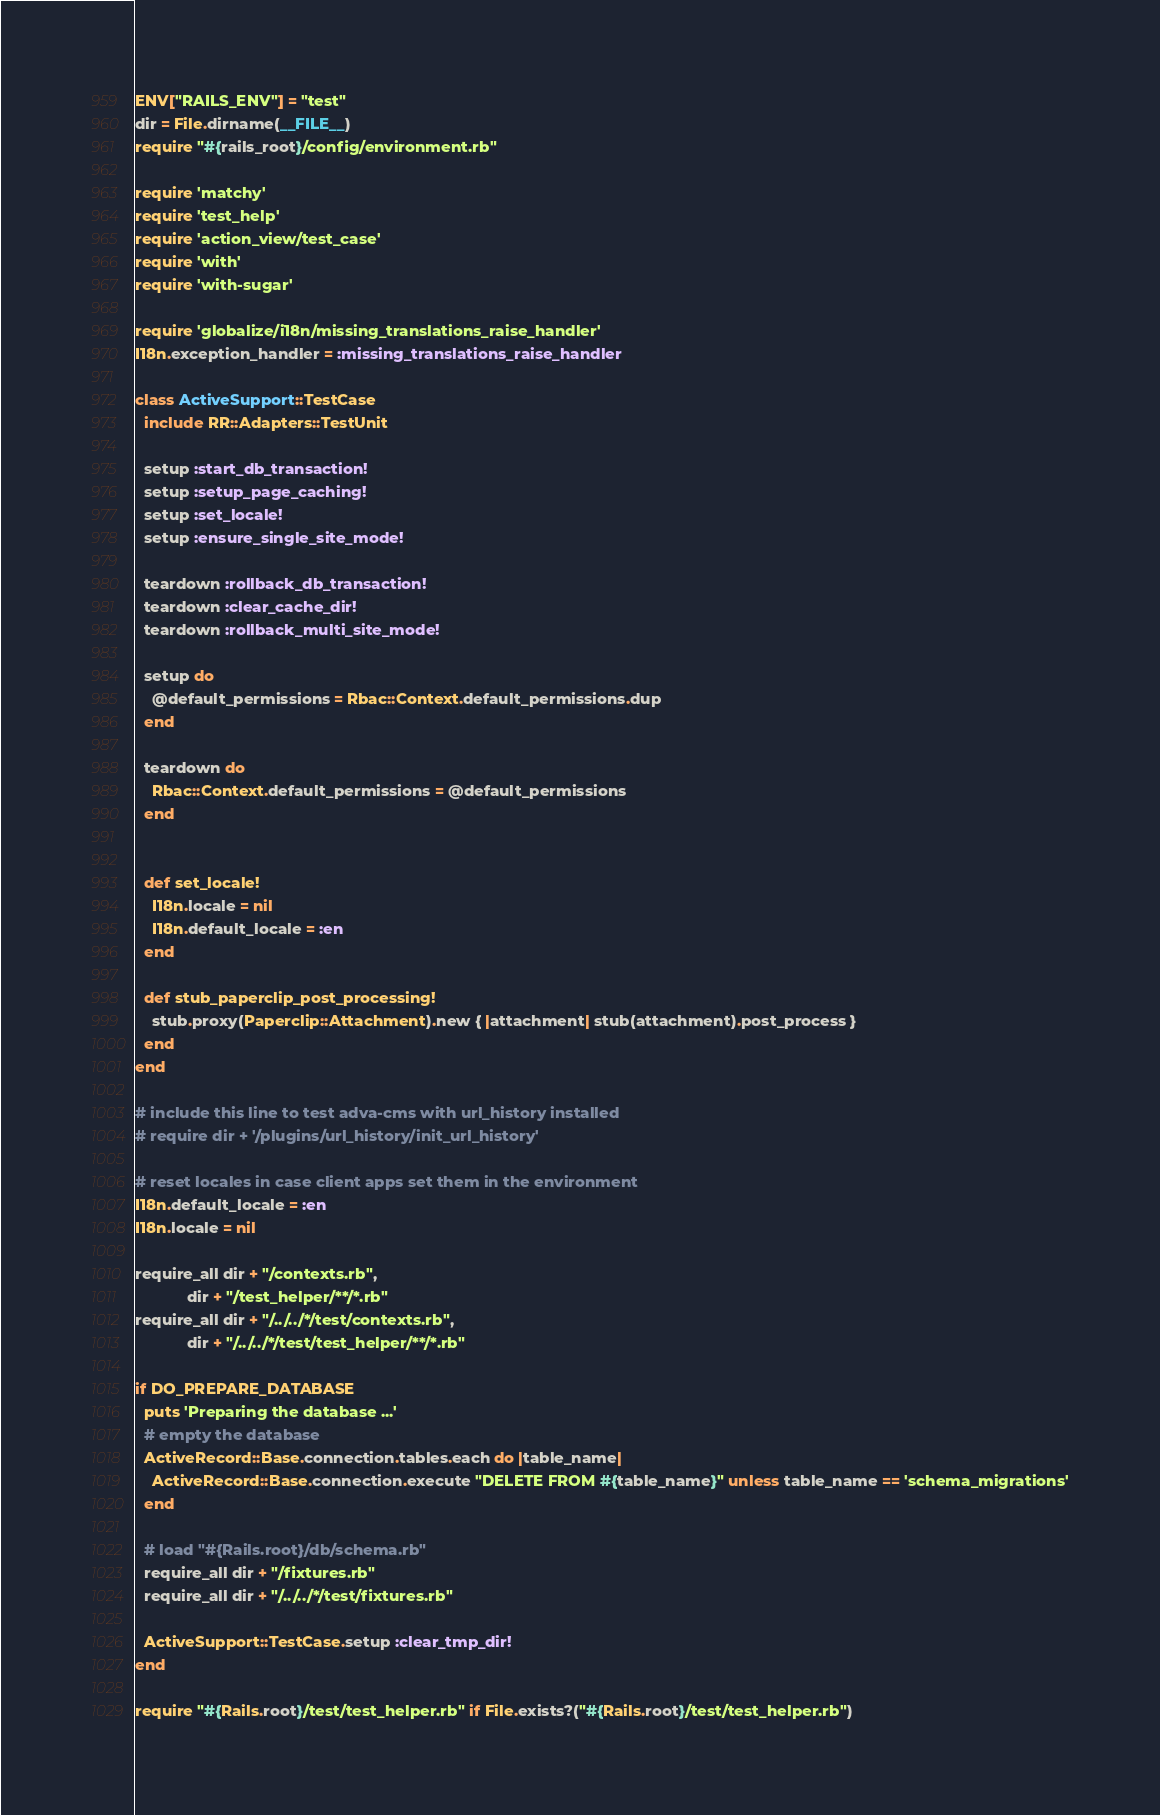<code> <loc_0><loc_0><loc_500><loc_500><_Ruby_>ENV["RAILS_ENV"] = "test"
dir = File.dirname(__FILE__)
require "#{rails_root}/config/environment.rb"

require 'matchy'
require 'test_help'
require 'action_view/test_case'
require 'with'
require 'with-sugar'

require 'globalize/i18n/missing_translations_raise_handler'
I18n.exception_handler = :missing_translations_raise_handler

class ActiveSupport::TestCase
  include RR::Adapters::TestUnit

  setup :start_db_transaction!
  setup :setup_page_caching!
  setup :set_locale!
  setup :ensure_single_site_mode!

  teardown :rollback_db_transaction!
  teardown :clear_cache_dir!
  teardown :rollback_multi_site_mode!
  
  setup do
    @default_permissions = Rbac::Context.default_permissions.dup
  end

  teardown do
    Rbac::Context.default_permissions = @default_permissions
  end
  
  
  def set_locale!
    I18n.locale = nil
    I18n.default_locale = :en
  end

  def stub_paperclip_post_processing!
    stub.proxy(Paperclip::Attachment).new { |attachment| stub(attachment).post_process }
  end
end

# include this line to test adva-cms with url_history installed
# require dir + '/plugins/url_history/init_url_history'

# reset locales in case client apps set them in the environment
I18n.default_locale = :en
I18n.locale = nil

require_all dir + "/contexts.rb",
            dir + "/test_helper/**/*.rb"
require_all dir + "/../../*/test/contexts.rb",
            dir + "/../../*/test/test_helper/**/*.rb"

if DO_PREPARE_DATABASE
  puts 'Preparing the database ...'
  # empty the database
  ActiveRecord::Base.connection.tables.each do |table_name|
    ActiveRecord::Base.connection.execute "DELETE FROM #{table_name}" unless table_name == 'schema_migrations'
  end

  # load "#{Rails.root}/db/schema.rb"
  require_all dir + "/fixtures.rb"
  require_all dir + "/../../*/test/fixtures.rb"
  
  ActiveSupport::TestCase.setup :clear_tmp_dir!
end

require "#{Rails.root}/test/test_helper.rb" if File.exists?("#{Rails.root}/test/test_helper.rb")
</code> 